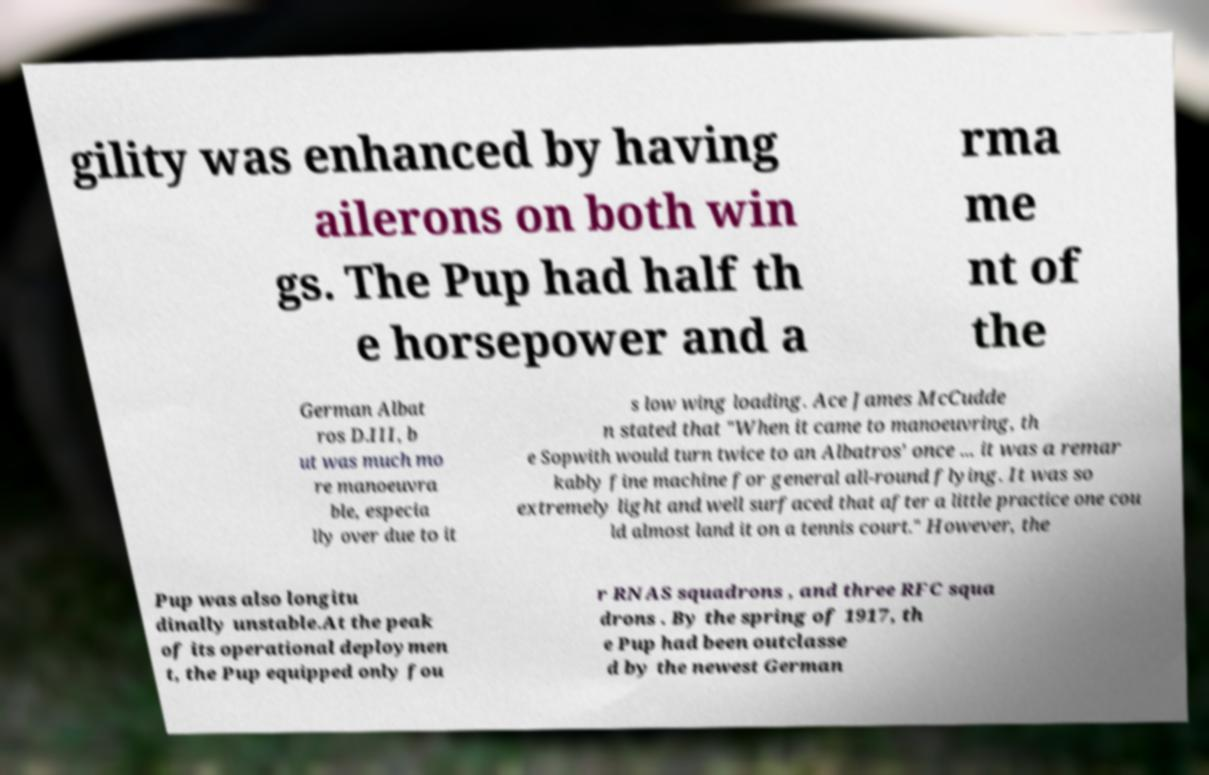What messages or text are displayed in this image? I need them in a readable, typed format. gility was enhanced by having ailerons on both win gs. The Pup had half th e horsepower and a rma me nt of the German Albat ros D.III, b ut was much mo re manoeuvra ble, especia lly over due to it s low wing loading. Ace James McCudde n stated that "When it came to manoeuvring, th e Sopwith would turn twice to an Albatros' once ... it was a remar kably fine machine for general all-round flying. It was so extremely light and well surfaced that after a little practice one cou ld almost land it on a tennis court." However, the Pup was also longitu dinally unstable.At the peak of its operational deploymen t, the Pup equipped only fou r RNAS squadrons , and three RFC squa drons . By the spring of 1917, th e Pup had been outclasse d by the newest German 